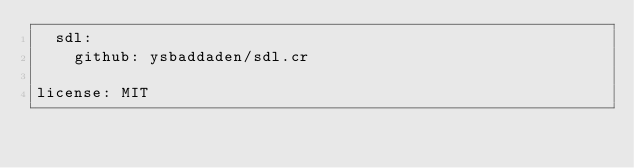Convert code to text. <code><loc_0><loc_0><loc_500><loc_500><_YAML_>  sdl:
    github: ysbaddaden/sdl.cr

license: MIT
</code> 